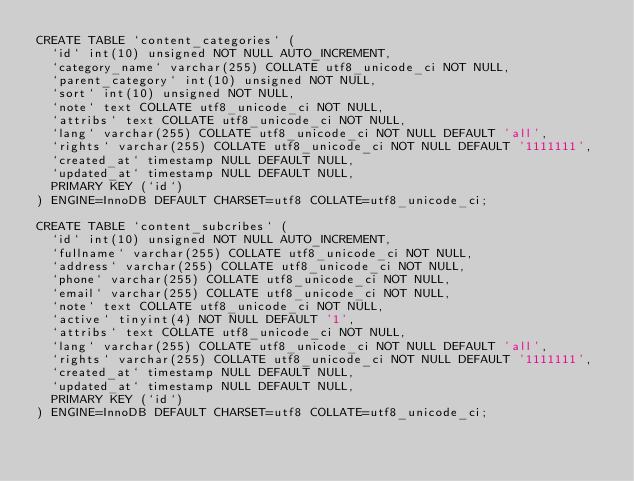<code> <loc_0><loc_0><loc_500><loc_500><_SQL_>CREATE TABLE `content_categories` (
  `id` int(10) unsigned NOT NULL AUTO_INCREMENT,
  `category_name` varchar(255) COLLATE utf8_unicode_ci NOT NULL,
  `parent_category` int(10) unsigned NOT NULL,
  `sort` int(10) unsigned NOT NULL,
  `note` text COLLATE utf8_unicode_ci NOT NULL,
  `attribs` text COLLATE utf8_unicode_ci NOT NULL,
  `lang` varchar(255) COLLATE utf8_unicode_ci NOT NULL DEFAULT 'all',
  `rights` varchar(255) COLLATE utf8_unicode_ci NOT NULL DEFAULT '1111111',
  `created_at` timestamp NULL DEFAULT NULL,
  `updated_at` timestamp NULL DEFAULT NULL,
  PRIMARY KEY (`id`)
) ENGINE=InnoDB DEFAULT CHARSET=utf8 COLLATE=utf8_unicode_ci;

CREATE TABLE `content_subcribes` (
  `id` int(10) unsigned NOT NULL AUTO_INCREMENT,
  `fullname` varchar(255) COLLATE utf8_unicode_ci NOT NULL,
  `address` varchar(255) COLLATE utf8_unicode_ci NOT NULL,
  `phone` varchar(255) COLLATE utf8_unicode_ci NOT NULL,
  `email` varchar(255) COLLATE utf8_unicode_ci NOT NULL,
  `note` text COLLATE utf8_unicode_ci NOT NULL,
  `active` tinyint(4) NOT NULL DEFAULT '1',
  `attribs` text COLLATE utf8_unicode_ci NOT NULL,
  `lang` varchar(255) COLLATE utf8_unicode_ci NOT NULL DEFAULT 'all',
  `rights` varchar(255) COLLATE utf8_unicode_ci NOT NULL DEFAULT '1111111',
  `created_at` timestamp NULL DEFAULT NULL,
  `updated_at` timestamp NULL DEFAULT NULL,
  PRIMARY KEY (`id`)
) ENGINE=InnoDB DEFAULT CHARSET=utf8 COLLATE=utf8_unicode_ci;
</code> 